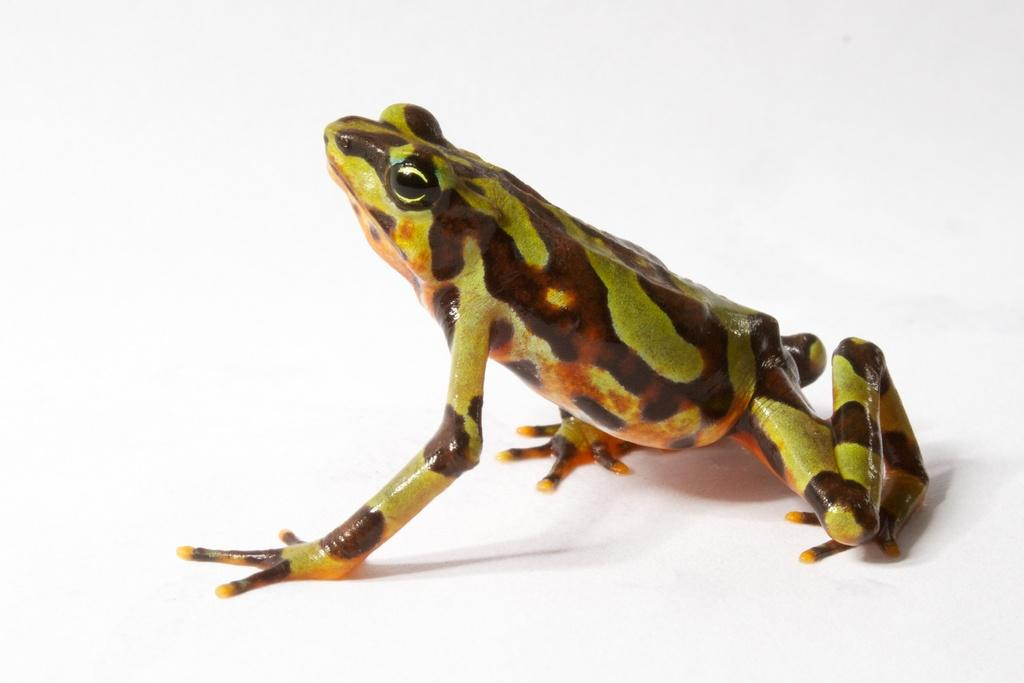What type of animal is in the image? There is a frog in the image. What is the color of the surface the frog is on? The frog is on a white surface. What type of toothpaste is the frog using in the image? There is no toothpaste present in the image, and the frog is not using any toothpaste. 